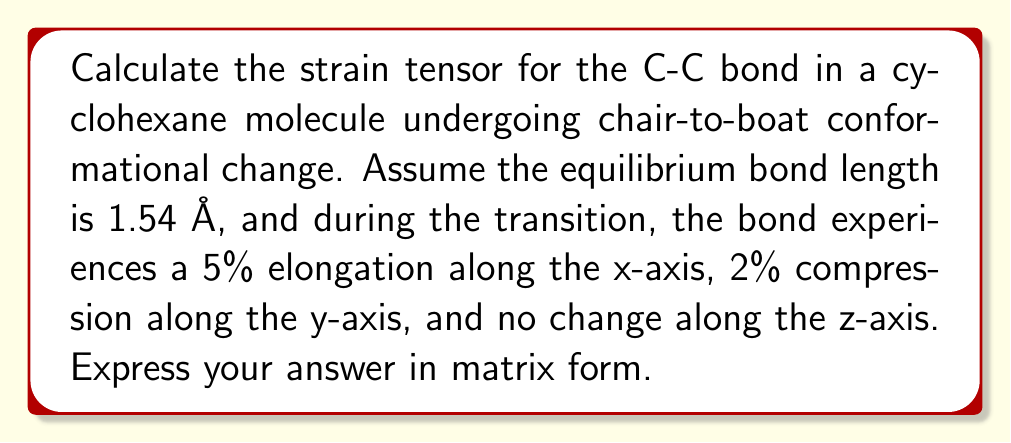Can you solve this math problem? To solve this problem, we'll follow these steps:

1) First, recall that the strain tensor $\varepsilon$ is a symmetric 3x3 matrix that represents the deformation of a body. For small deformations, the components are given by:

   $$\varepsilon_{ij} = \frac{1}{2}\left(\frac{\partial u_i}{\partial x_j} + \frac{\partial u_j}{\partial x_i}\right)$$

   where $u_i$ is the displacement in the i-th direction.

2) In this case, we're given the relative changes in each direction:
   - x-axis: 5% elongation (0.05)
   - y-axis: 2% compression (-0.02)
   - z-axis: no change (0)

3) For a uniform strain, the diagonal elements of the strain tensor represent these relative changes directly:

   $$\varepsilon_{xx} = 0.05$$
   $$\varepsilon_{yy} = -0.02$$
   $$\varepsilon_{zz} = 0$$

4) Since there's no information about shear strains, we assume they are zero:

   $$\varepsilon_{xy} = \varepsilon_{yx} = \varepsilon_{yz} = \varepsilon_{zy} = \varepsilon_{xz} = \varepsilon_{zx} = 0$$

5) Now we can construct the strain tensor in matrix form:

   $$\varepsilon = \begin{bmatrix}
   0.05 & 0 & 0 \\
   0 & -0.02 & 0 \\
   0 & 0 & 0
   \end{bmatrix}$$

This tensor represents the molecular bond strain in the C-C bond during the chair-to-boat conformational change of cyclohexane.
Answer: $$\varepsilon = \begin{bmatrix}
0.05 & 0 & 0 \\
0 & -0.02 & 0 \\
0 & 0 & 0
\end{bmatrix}$$ 